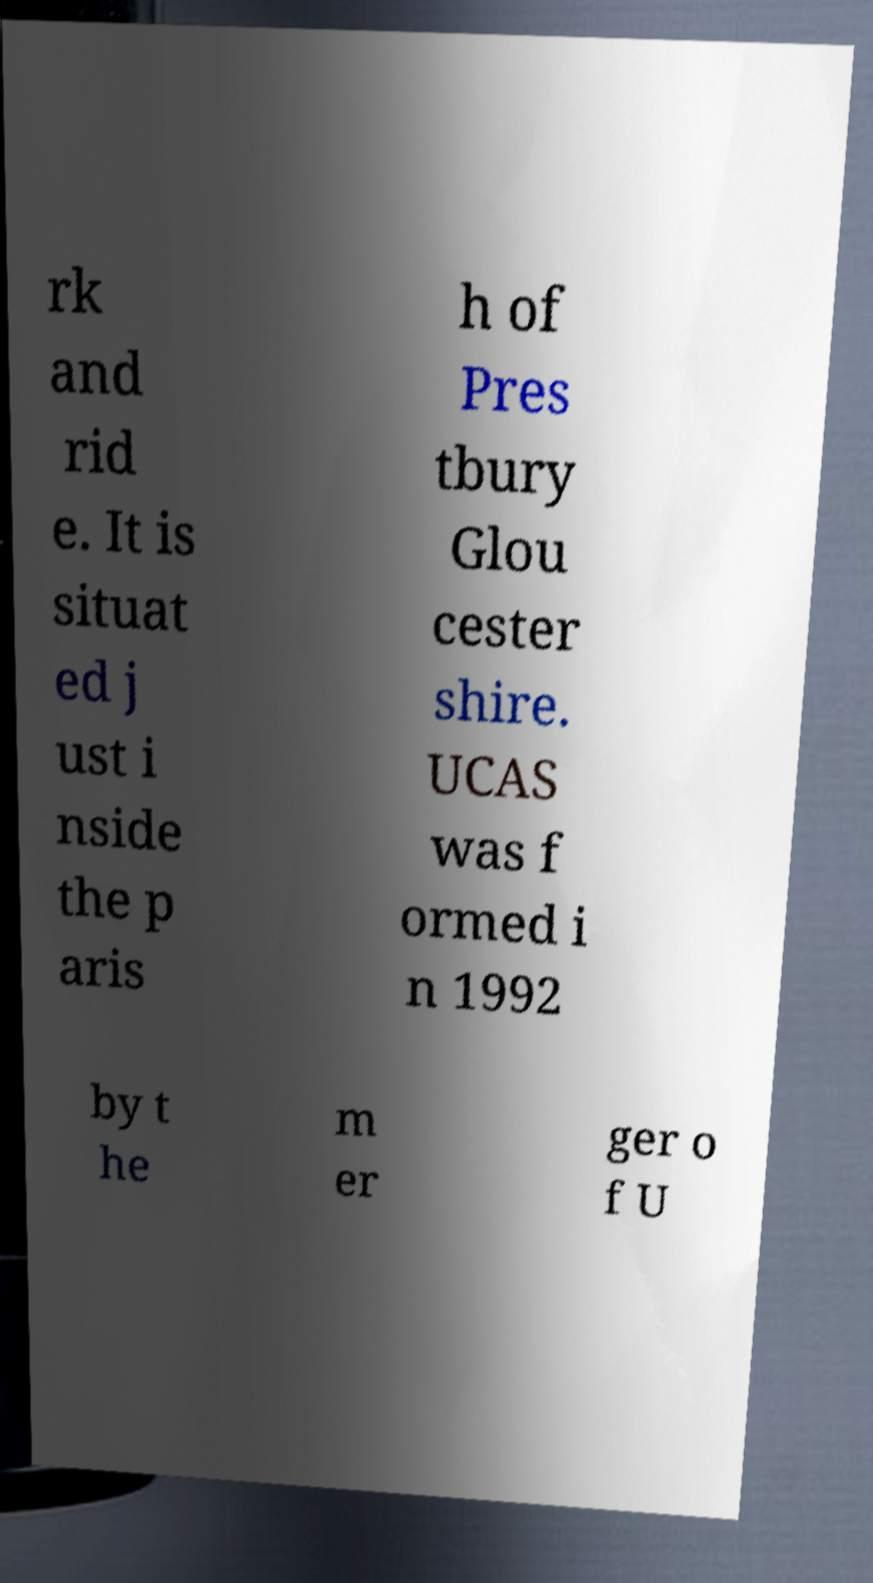For documentation purposes, I need the text within this image transcribed. Could you provide that? rk and rid e. It is situat ed j ust i nside the p aris h of Pres tbury Glou cester shire. UCAS was f ormed i n 1992 by t he m er ger o f U 